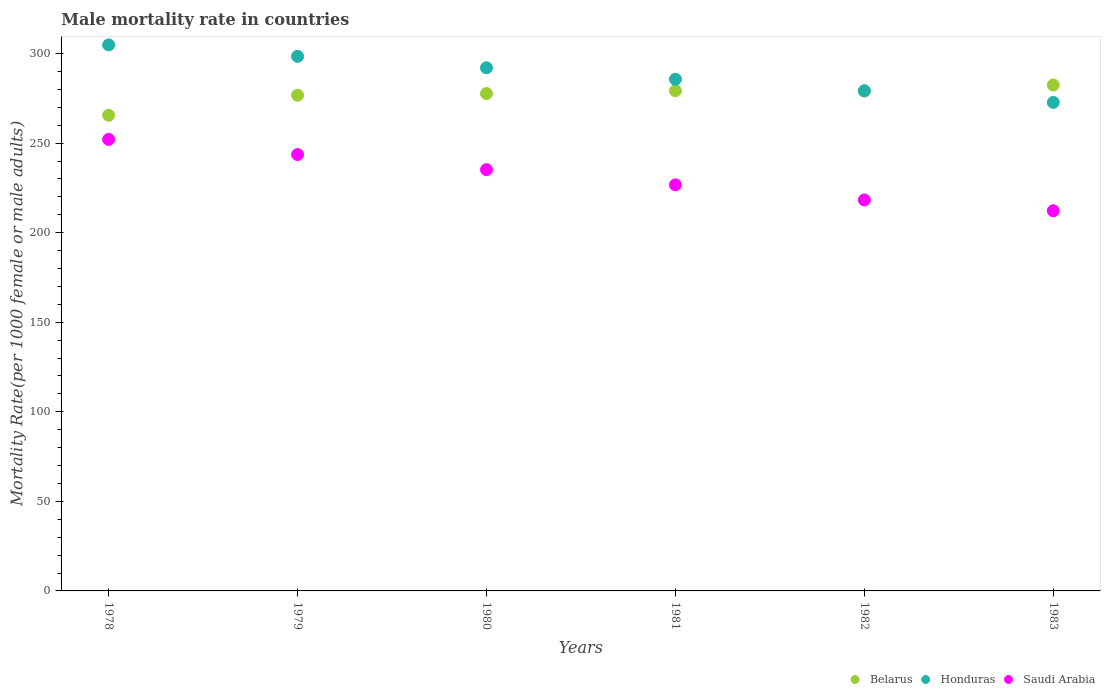How many different coloured dotlines are there?
Your answer should be compact. 3. What is the male mortality rate in Saudi Arabia in 1983?
Your answer should be compact. 212.25. Across all years, what is the maximum male mortality rate in Honduras?
Keep it short and to the point. 304.86. Across all years, what is the minimum male mortality rate in Honduras?
Offer a very short reply. 272.74. In which year was the male mortality rate in Saudi Arabia maximum?
Your response must be concise. 1978. In which year was the male mortality rate in Honduras minimum?
Provide a succinct answer. 1983. What is the total male mortality rate in Saudi Arabia in the graph?
Your answer should be compact. 1388.11. What is the difference between the male mortality rate in Belarus in 1978 and that in 1981?
Provide a succinct answer. -13.7. What is the difference between the male mortality rate in Saudi Arabia in 1983 and the male mortality rate in Belarus in 1982?
Your response must be concise. -66.8. What is the average male mortality rate in Saudi Arabia per year?
Your answer should be compact. 231.35. In the year 1983, what is the difference between the male mortality rate in Belarus and male mortality rate in Saudi Arabia?
Your response must be concise. 70.23. What is the ratio of the male mortality rate in Saudi Arabia in 1979 to that in 1982?
Keep it short and to the point. 1.12. Is the male mortality rate in Belarus in 1979 less than that in 1982?
Your answer should be compact. Yes. Is the difference between the male mortality rate in Belarus in 1979 and 1981 greater than the difference between the male mortality rate in Saudi Arabia in 1979 and 1981?
Your answer should be very brief. No. What is the difference between the highest and the second highest male mortality rate in Honduras?
Ensure brevity in your answer.  6.4. What is the difference between the highest and the lowest male mortality rate in Saudi Arabia?
Ensure brevity in your answer.  39.82. In how many years, is the male mortality rate in Honduras greater than the average male mortality rate in Honduras taken over all years?
Your response must be concise. 3. Is it the case that in every year, the sum of the male mortality rate in Belarus and male mortality rate in Honduras  is greater than the male mortality rate in Saudi Arabia?
Make the answer very short. Yes. Is the male mortality rate in Belarus strictly greater than the male mortality rate in Saudi Arabia over the years?
Your response must be concise. Yes. How many dotlines are there?
Provide a succinct answer. 3. How many years are there in the graph?
Offer a very short reply. 6. Does the graph contain grids?
Provide a succinct answer. No. Where does the legend appear in the graph?
Provide a short and direct response. Bottom right. How many legend labels are there?
Offer a terse response. 3. How are the legend labels stacked?
Your answer should be compact. Horizontal. What is the title of the graph?
Your answer should be compact. Male mortality rate in countries. What is the label or title of the X-axis?
Make the answer very short. Years. What is the label or title of the Y-axis?
Ensure brevity in your answer.  Mortality Rate(per 1000 female or male adults). What is the Mortality Rate(per 1000 female or male adults) in Belarus in 1978?
Offer a terse response. 265.55. What is the Mortality Rate(per 1000 female or male adults) in Honduras in 1978?
Your answer should be compact. 304.86. What is the Mortality Rate(per 1000 female or male adults) in Saudi Arabia in 1978?
Give a very brief answer. 252.07. What is the Mortality Rate(per 1000 female or male adults) in Belarus in 1979?
Your answer should be very brief. 276.74. What is the Mortality Rate(per 1000 female or male adults) in Honduras in 1979?
Provide a succinct answer. 298.46. What is the Mortality Rate(per 1000 female or male adults) in Saudi Arabia in 1979?
Give a very brief answer. 243.62. What is the Mortality Rate(per 1000 female or male adults) in Belarus in 1980?
Provide a short and direct response. 277.67. What is the Mortality Rate(per 1000 female or male adults) of Honduras in 1980?
Your answer should be very brief. 292.06. What is the Mortality Rate(per 1000 female or male adults) in Saudi Arabia in 1980?
Provide a succinct answer. 235.17. What is the Mortality Rate(per 1000 female or male adults) of Belarus in 1981?
Your answer should be very brief. 279.25. What is the Mortality Rate(per 1000 female or male adults) in Honduras in 1981?
Keep it short and to the point. 285.67. What is the Mortality Rate(per 1000 female or male adults) in Saudi Arabia in 1981?
Provide a short and direct response. 226.72. What is the Mortality Rate(per 1000 female or male adults) in Belarus in 1982?
Ensure brevity in your answer.  279.05. What is the Mortality Rate(per 1000 female or male adults) of Honduras in 1982?
Offer a very short reply. 279.27. What is the Mortality Rate(per 1000 female or male adults) in Saudi Arabia in 1982?
Offer a very short reply. 218.28. What is the Mortality Rate(per 1000 female or male adults) of Belarus in 1983?
Provide a short and direct response. 282.48. What is the Mortality Rate(per 1000 female or male adults) in Honduras in 1983?
Provide a succinct answer. 272.74. What is the Mortality Rate(per 1000 female or male adults) in Saudi Arabia in 1983?
Your response must be concise. 212.25. Across all years, what is the maximum Mortality Rate(per 1000 female or male adults) of Belarus?
Ensure brevity in your answer.  282.48. Across all years, what is the maximum Mortality Rate(per 1000 female or male adults) in Honduras?
Keep it short and to the point. 304.86. Across all years, what is the maximum Mortality Rate(per 1000 female or male adults) of Saudi Arabia?
Ensure brevity in your answer.  252.07. Across all years, what is the minimum Mortality Rate(per 1000 female or male adults) in Belarus?
Offer a terse response. 265.55. Across all years, what is the minimum Mortality Rate(per 1000 female or male adults) in Honduras?
Your answer should be compact. 272.74. Across all years, what is the minimum Mortality Rate(per 1000 female or male adults) of Saudi Arabia?
Provide a succinct answer. 212.25. What is the total Mortality Rate(per 1000 female or male adults) in Belarus in the graph?
Give a very brief answer. 1660.72. What is the total Mortality Rate(per 1000 female or male adults) in Honduras in the graph?
Provide a succinct answer. 1733.06. What is the total Mortality Rate(per 1000 female or male adults) of Saudi Arabia in the graph?
Make the answer very short. 1388.11. What is the difference between the Mortality Rate(per 1000 female or male adults) of Belarus in 1978 and that in 1979?
Offer a very short reply. -11.19. What is the difference between the Mortality Rate(per 1000 female or male adults) of Honduras in 1978 and that in 1979?
Ensure brevity in your answer.  6.4. What is the difference between the Mortality Rate(per 1000 female or male adults) in Saudi Arabia in 1978 and that in 1979?
Give a very brief answer. 8.45. What is the difference between the Mortality Rate(per 1000 female or male adults) in Belarus in 1978 and that in 1980?
Provide a succinct answer. -12.12. What is the difference between the Mortality Rate(per 1000 female or male adults) in Honduras in 1978 and that in 1980?
Offer a very short reply. 12.79. What is the difference between the Mortality Rate(per 1000 female or male adults) in Saudi Arabia in 1978 and that in 1980?
Keep it short and to the point. 16.9. What is the difference between the Mortality Rate(per 1000 female or male adults) in Belarus in 1978 and that in 1981?
Your response must be concise. -13.7. What is the difference between the Mortality Rate(per 1000 female or male adults) in Honduras in 1978 and that in 1981?
Offer a very short reply. 19.19. What is the difference between the Mortality Rate(per 1000 female or male adults) in Saudi Arabia in 1978 and that in 1981?
Ensure brevity in your answer.  25.34. What is the difference between the Mortality Rate(per 1000 female or male adults) of Belarus in 1978 and that in 1982?
Your answer should be very brief. -13.51. What is the difference between the Mortality Rate(per 1000 female or male adults) in Honduras in 1978 and that in 1982?
Provide a succinct answer. 25.59. What is the difference between the Mortality Rate(per 1000 female or male adults) in Saudi Arabia in 1978 and that in 1982?
Make the answer very short. 33.79. What is the difference between the Mortality Rate(per 1000 female or male adults) in Belarus in 1978 and that in 1983?
Keep it short and to the point. -16.93. What is the difference between the Mortality Rate(per 1000 female or male adults) of Honduras in 1978 and that in 1983?
Offer a terse response. 32.12. What is the difference between the Mortality Rate(per 1000 female or male adults) of Saudi Arabia in 1978 and that in 1983?
Your answer should be very brief. 39.82. What is the difference between the Mortality Rate(per 1000 female or male adults) of Belarus in 1979 and that in 1980?
Ensure brevity in your answer.  -0.93. What is the difference between the Mortality Rate(per 1000 female or male adults) in Honduras in 1979 and that in 1980?
Your answer should be compact. 6.4. What is the difference between the Mortality Rate(per 1000 female or male adults) in Saudi Arabia in 1979 and that in 1980?
Offer a very short reply. 8.45. What is the difference between the Mortality Rate(per 1000 female or male adults) of Belarus in 1979 and that in 1981?
Make the answer very short. -2.51. What is the difference between the Mortality Rate(per 1000 female or male adults) of Honduras in 1979 and that in 1981?
Provide a short and direct response. 12.79. What is the difference between the Mortality Rate(per 1000 female or male adults) in Saudi Arabia in 1979 and that in 1981?
Your answer should be very brief. 16.9. What is the difference between the Mortality Rate(per 1000 female or male adults) in Belarus in 1979 and that in 1982?
Give a very brief answer. -2.31. What is the difference between the Mortality Rate(per 1000 female or male adults) in Honduras in 1979 and that in 1982?
Keep it short and to the point. 19.19. What is the difference between the Mortality Rate(per 1000 female or male adults) of Saudi Arabia in 1979 and that in 1982?
Provide a succinct answer. 25.34. What is the difference between the Mortality Rate(per 1000 female or male adults) in Belarus in 1979 and that in 1983?
Offer a terse response. -5.74. What is the difference between the Mortality Rate(per 1000 female or male adults) of Honduras in 1979 and that in 1983?
Offer a terse response. 25.72. What is the difference between the Mortality Rate(per 1000 female or male adults) of Saudi Arabia in 1979 and that in 1983?
Ensure brevity in your answer.  31.37. What is the difference between the Mortality Rate(per 1000 female or male adults) of Belarus in 1980 and that in 1981?
Provide a succinct answer. -1.58. What is the difference between the Mortality Rate(per 1000 female or male adults) of Honduras in 1980 and that in 1981?
Ensure brevity in your answer.  6.4. What is the difference between the Mortality Rate(per 1000 female or male adults) of Saudi Arabia in 1980 and that in 1981?
Provide a succinct answer. 8.45. What is the difference between the Mortality Rate(per 1000 female or male adults) of Belarus in 1980 and that in 1982?
Your response must be concise. -1.39. What is the difference between the Mortality Rate(per 1000 female or male adults) of Honduras in 1980 and that in 1982?
Provide a succinct answer. 12.79. What is the difference between the Mortality Rate(per 1000 female or male adults) in Saudi Arabia in 1980 and that in 1982?
Keep it short and to the point. 16.9. What is the difference between the Mortality Rate(per 1000 female or male adults) of Belarus in 1980 and that in 1983?
Make the answer very short. -4.81. What is the difference between the Mortality Rate(per 1000 female or male adults) in Honduras in 1980 and that in 1983?
Keep it short and to the point. 19.32. What is the difference between the Mortality Rate(per 1000 female or male adults) of Saudi Arabia in 1980 and that in 1983?
Offer a very short reply. 22.92. What is the difference between the Mortality Rate(per 1000 female or male adults) of Belarus in 1981 and that in 1982?
Give a very brief answer. 0.19. What is the difference between the Mortality Rate(per 1000 female or male adults) of Honduras in 1981 and that in 1982?
Provide a succinct answer. 6.4. What is the difference between the Mortality Rate(per 1000 female or male adults) of Saudi Arabia in 1981 and that in 1982?
Ensure brevity in your answer.  8.45. What is the difference between the Mortality Rate(per 1000 female or male adults) in Belarus in 1981 and that in 1983?
Give a very brief answer. -3.23. What is the difference between the Mortality Rate(per 1000 female or male adults) of Honduras in 1981 and that in 1983?
Provide a short and direct response. 12.93. What is the difference between the Mortality Rate(per 1000 female or male adults) in Saudi Arabia in 1981 and that in 1983?
Provide a succinct answer. 14.48. What is the difference between the Mortality Rate(per 1000 female or male adults) of Belarus in 1982 and that in 1983?
Your answer should be compact. -3.42. What is the difference between the Mortality Rate(per 1000 female or male adults) in Honduras in 1982 and that in 1983?
Offer a very short reply. 6.53. What is the difference between the Mortality Rate(per 1000 female or male adults) in Saudi Arabia in 1982 and that in 1983?
Your response must be concise. 6.03. What is the difference between the Mortality Rate(per 1000 female or male adults) of Belarus in 1978 and the Mortality Rate(per 1000 female or male adults) of Honduras in 1979?
Keep it short and to the point. -32.91. What is the difference between the Mortality Rate(per 1000 female or male adults) of Belarus in 1978 and the Mortality Rate(per 1000 female or male adults) of Saudi Arabia in 1979?
Your answer should be compact. 21.93. What is the difference between the Mortality Rate(per 1000 female or male adults) of Honduras in 1978 and the Mortality Rate(per 1000 female or male adults) of Saudi Arabia in 1979?
Keep it short and to the point. 61.24. What is the difference between the Mortality Rate(per 1000 female or male adults) in Belarus in 1978 and the Mortality Rate(per 1000 female or male adults) in Honduras in 1980?
Your answer should be very brief. -26.52. What is the difference between the Mortality Rate(per 1000 female or male adults) of Belarus in 1978 and the Mortality Rate(per 1000 female or male adults) of Saudi Arabia in 1980?
Your answer should be very brief. 30.37. What is the difference between the Mortality Rate(per 1000 female or male adults) in Honduras in 1978 and the Mortality Rate(per 1000 female or male adults) in Saudi Arabia in 1980?
Your answer should be compact. 69.69. What is the difference between the Mortality Rate(per 1000 female or male adults) of Belarus in 1978 and the Mortality Rate(per 1000 female or male adults) of Honduras in 1981?
Your answer should be very brief. -20.12. What is the difference between the Mortality Rate(per 1000 female or male adults) of Belarus in 1978 and the Mortality Rate(per 1000 female or male adults) of Saudi Arabia in 1981?
Provide a short and direct response. 38.82. What is the difference between the Mortality Rate(per 1000 female or male adults) in Honduras in 1978 and the Mortality Rate(per 1000 female or male adults) in Saudi Arabia in 1981?
Provide a short and direct response. 78.13. What is the difference between the Mortality Rate(per 1000 female or male adults) in Belarus in 1978 and the Mortality Rate(per 1000 female or male adults) in Honduras in 1982?
Your answer should be compact. -13.73. What is the difference between the Mortality Rate(per 1000 female or male adults) of Belarus in 1978 and the Mortality Rate(per 1000 female or male adults) of Saudi Arabia in 1982?
Provide a short and direct response. 47.27. What is the difference between the Mortality Rate(per 1000 female or male adults) in Honduras in 1978 and the Mortality Rate(per 1000 female or male adults) in Saudi Arabia in 1982?
Your response must be concise. 86.58. What is the difference between the Mortality Rate(per 1000 female or male adults) in Belarus in 1978 and the Mortality Rate(per 1000 female or male adults) in Honduras in 1983?
Provide a short and direct response. -7.2. What is the difference between the Mortality Rate(per 1000 female or male adults) of Belarus in 1978 and the Mortality Rate(per 1000 female or male adults) of Saudi Arabia in 1983?
Keep it short and to the point. 53.3. What is the difference between the Mortality Rate(per 1000 female or male adults) of Honduras in 1978 and the Mortality Rate(per 1000 female or male adults) of Saudi Arabia in 1983?
Your answer should be compact. 92.61. What is the difference between the Mortality Rate(per 1000 female or male adults) of Belarus in 1979 and the Mortality Rate(per 1000 female or male adults) of Honduras in 1980?
Your answer should be compact. -15.32. What is the difference between the Mortality Rate(per 1000 female or male adults) of Belarus in 1979 and the Mortality Rate(per 1000 female or male adults) of Saudi Arabia in 1980?
Make the answer very short. 41.57. What is the difference between the Mortality Rate(per 1000 female or male adults) in Honduras in 1979 and the Mortality Rate(per 1000 female or male adults) in Saudi Arabia in 1980?
Provide a short and direct response. 63.29. What is the difference between the Mortality Rate(per 1000 female or male adults) of Belarus in 1979 and the Mortality Rate(per 1000 female or male adults) of Honduras in 1981?
Offer a terse response. -8.93. What is the difference between the Mortality Rate(per 1000 female or male adults) of Belarus in 1979 and the Mortality Rate(per 1000 female or male adults) of Saudi Arabia in 1981?
Make the answer very short. 50.02. What is the difference between the Mortality Rate(per 1000 female or male adults) of Honduras in 1979 and the Mortality Rate(per 1000 female or male adults) of Saudi Arabia in 1981?
Your answer should be very brief. 71.74. What is the difference between the Mortality Rate(per 1000 female or male adults) in Belarus in 1979 and the Mortality Rate(per 1000 female or male adults) in Honduras in 1982?
Your response must be concise. -2.53. What is the difference between the Mortality Rate(per 1000 female or male adults) of Belarus in 1979 and the Mortality Rate(per 1000 female or male adults) of Saudi Arabia in 1982?
Ensure brevity in your answer.  58.46. What is the difference between the Mortality Rate(per 1000 female or male adults) of Honduras in 1979 and the Mortality Rate(per 1000 female or male adults) of Saudi Arabia in 1982?
Keep it short and to the point. 80.19. What is the difference between the Mortality Rate(per 1000 female or male adults) in Belarus in 1979 and the Mortality Rate(per 1000 female or male adults) in Honduras in 1983?
Your answer should be compact. 4. What is the difference between the Mortality Rate(per 1000 female or male adults) of Belarus in 1979 and the Mortality Rate(per 1000 female or male adults) of Saudi Arabia in 1983?
Make the answer very short. 64.49. What is the difference between the Mortality Rate(per 1000 female or male adults) of Honduras in 1979 and the Mortality Rate(per 1000 female or male adults) of Saudi Arabia in 1983?
Make the answer very short. 86.21. What is the difference between the Mortality Rate(per 1000 female or male adults) of Belarus in 1980 and the Mortality Rate(per 1000 female or male adults) of Honduras in 1981?
Your response must be concise. -8. What is the difference between the Mortality Rate(per 1000 female or male adults) of Belarus in 1980 and the Mortality Rate(per 1000 female or male adults) of Saudi Arabia in 1981?
Ensure brevity in your answer.  50.94. What is the difference between the Mortality Rate(per 1000 female or male adults) in Honduras in 1980 and the Mortality Rate(per 1000 female or male adults) in Saudi Arabia in 1981?
Offer a very short reply. 65.34. What is the difference between the Mortality Rate(per 1000 female or male adults) in Belarus in 1980 and the Mortality Rate(per 1000 female or male adults) in Honduras in 1982?
Your answer should be compact. -1.61. What is the difference between the Mortality Rate(per 1000 female or male adults) of Belarus in 1980 and the Mortality Rate(per 1000 female or male adults) of Saudi Arabia in 1982?
Provide a short and direct response. 59.39. What is the difference between the Mortality Rate(per 1000 female or male adults) of Honduras in 1980 and the Mortality Rate(per 1000 female or male adults) of Saudi Arabia in 1982?
Your answer should be very brief. 73.79. What is the difference between the Mortality Rate(per 1000 female or male adults) of Belarus in 1980 and the Mortality Rate(per 1000 female or male adults) of Honduras in 1983?
Your answer should be very brief. 4.92. What is the difference between the Mortality Rate(per 1000 female or male adults) of Belarus in 1980 and the Mortality Rate(per 1000 female or male adults) of Saudi Arabia in 1983?
Offer a terse response. 65.42. What is the difference between the Mortality Rate(per 1000 female or male adults) of Honduras in 1980 and the Mortality Rate(per 1000 female or male adults) of Saudi Arabia in 1983?
Provide a short and direct response. 79.82. What is the difference between the Mortality Rate(per 1000 female or male adults) of Belarus in 1981 and the Mortality Rate(per 1000 female or male adults) of Honduras in 1982?
Offer a very short reply. -0.03. What is the difference between the Mortality Rate(per 1000 female or male adults) of Belarus in 1981 and the Mortality Rate(per 1000 female or male adults) of Saudi Arabia in 1982?
Your answer should be very brief. 60.97. What is the difference between the Mortality Rate(per 1000 female or male adults) in Honduras in 1981 and the Mortality Rate(per 1000 female or male adults) in Saudi Arabia in 1982?
Your response must be concise. 67.39. What is the difference between the Mortality Rate(per 1000 female or male adults) in Belarus in 1981 and the Mortality Rate(per 1000 female or male adults) in Honduras in 1983?
Ensure brevity in your answer.  6.5. What is the difference between the Mortality Rate(per 1000 female or male adults) of Belarus in 1981 and the Mortality Rate(per 1000 female or male adults) of Saudi Arabia in 1983?
Your answer should be very brief. 67. What is the difference between the Mortality Rate(per 1000 female or male adults) of Honduras in 1981 and the Mortality Rate(per 1000 female or male adults) of Saudi Arabia in 1983?
Provide a succinct answer. 73.42. What is the difference between the Mortality Rate(per 1000 female or male adults) in Belarus in 1982 and the Mortality Rate(per 1000 female or male adults) in Honduras in 1983?
Provide a short and direct response. 6.31. What is the difference between the Mortality Rate(per 1000 female or male adults) of Belarus in 1982 and the Mortality Rate(per 1000 female or male adults) of Saudi Arabia in 1983?
Provide a short and direct response. 66.8. What is the difference between the Mortality Rate(per 1000 female or male adults) of Honduras in 1982 and the Mortality Rate(per 1000 female or male adults) of Saudi Arabia in 1983?
Offer a terse response. 67.02. What is the average Mortality Rate(per 1000 female or male adults) in Belarus per year?
Offer a very short reply. 276.79. What is the average Mortality Rate(per 1000 female or male adults) of Honduras per year?
Keep it short and to the point. 288.84. What is the average Mortality Rate(per 1000 female or male adults) in Saudi Arabia per year?
Provide a succinct answer. 231.35. In the year 1978, what is the difference between the Mortality Rate(per 1000 female or male adults) in Belarus and Mortality Rate(per 1000 female or male adults) in Honduras?
Offer a very short reply. -39.31. In the year 1978, what is the difference between the Mortality Rate(per 1000 female or male adults) in Belarus and Mortality Rate(per 1000 female or male adults) in Saudi Arabia?
Your answer should be compact. 13.48. In the year 1978, what is the difference between the Mortality Rate(per 1000 female or male adults) in Honduras and Mortality Rate(per 1000 female or male adults) in Saudi Arabia?
Give a very brief answer. 52.79. In the year 1979, what is the difference between the Mortality Rate(per 1000 female or male adults) in Belarus and Mortality Rate(per 1000 female or male adults) in Honduras?
Keep it short and to the point. -21.72. In the year 1979, what is the difference between the Mortality Rate(per 1000 female or male adults) in Belarus and Mortality Rate(per 1000 female or male adults) in Saudi Arabia?
Make the answer very short. 33.12. In the year 1979, what is the difference between the Mortality Rate(per 1000 female or male adults) in Honduras and Mortality Rate(per 1000 female or male adults) in Saudi Arabia?
Offer a very short reply. 54.84. In the year 1980, what is the difference between the Mortality Rate(per 1000 female or male adults) in Belarus and Mortality Rate(per 1000 female or male adults) in Honduras?
Offer a terse response. -14.4. In the year 1980, what is the difference between the Mortality Rate(per 1000 female or male adults) of Belarus and Mortality Rate(per 1000 female or male adults) of Saudi Arabia?
Provide a short and direct response. 42.49. In the year 1980, what is the difference between the Mortality Rate(per 1000 female or male adults) of Honduras and Mortality Rate(per 1000 female or male adults) of Saudi Arabia?
Keep it short and to the point. 56.89. In the year 1981, what is the difference between the Mortality Rate(per 1000 female or male adults) in Belarus and Mortality Rate(per 1000 female or male adults) in Honduras?
Offer a terse response. -6.42. In the year 1981, what is the difference between the Mortality Rate(per 1000 female or male adults) in Belarus and Mortality Rate(per 1000 female or male adults) in Saudi Arabia?
Your answer should be very brief. 52.52. In the year 1981, what is the difference between the Mortality Rate(per 1000 female or male adults) of Honduras and Mortality Rate(per 1000 female or male adults) of Saudi Arabia?
Keep it short and to the point. 58.94. In the year 1982, what is the difference between the Mortality Rate(per 1000 female or male adults) of Belarus and Mortality Rate(per 1000 female or male adults) of Honduras?
Make the answer very short. -0.22. In the year 1982, what is the difference between the Mortality Rate(per 1000 female or male adults) of Belarus and Mortality Rate(per 1000 female or male adults) of Saudi Arabia?
Provide a succinct answer. 60.78. In the year 1982, what is the difference between the Mortality Rate(per 1000 female or male adults) of Honduras and Mortality Rate(per 1000 female or male adults) of Saudi Arabia?
Keep it short and to the point. 61. In the year 1983, what is the difference between the Mortality Rate(per 1000 female or male adults) of Belarus and Mortality Rate(per 1000 female or male adults) of Honduras?
Provide a succinct answer. 9.73. In the year 1983, what is the difference between the Mortality Rate(per 1000 female or male adults) of Belarus and Mortality Rate(per 1000 female or male adults) of Saudi Arabia?
Your answer should be compact. 70.23. In the year 1983, what is the difference between the Mortality Rate(per 1000 female or male adults) in Honduras and Mortality Rate(per 1000 female or male adults) in Saudi Arabia?
Give a very brief answer. 60.49. What is the ratio of the Mortality Rate(per 1000 female or male adults) of Belarus in 1978 to that in 1979?
Give a very brief answer. 0.96. What is the ratio of the Mortality Rate(per 1000 female or male adults) of Honduras in 1978 to that in 1979?
Offer a very short reply. 1.02. What is the ratio of the Mortality Rate(per 1000 female or male adults) in Saudi Arabia in 1978 to that in 1979?
Make the answer very short. 1.03. What is the ratio of the Mortality Rate(per 1000 female or male adults) in Belarus in 1978 to that in 1980?
Give a very brief answer. 0.96. What is the ratio of the Mortality Rate(per 1000 female or male adults) of Honduras in 1978 to that in 1980?
Offer a terse response. 1.04. What is the ratio of the Mortality Rate(per 1000 female or male adults) in Saudi Arabia in 1978 to that in 1980?
Provide a short and direct response. 1.07. What is the ratio of the Mortality Rate(per 1000 female or male adults) in Belarus in 1978 to that in 1981?
Give a very brief answer. 0.95. What is the ratio of the Mortality Rate(per 1000 female or male adults) of Honduras in 1978 to that in 1981?
Your response must be concise. 1.07. What is the ratio of the Mortality Rate(per 1000 female or male adults) of Saudi Arabia in 1978 to that in 1981?
Offer a terse response. 1.11. What is the ratio of the Mortality Rate(per 1000 female or male adults) in Belarus in 1978 to that in 1982?
Offer a terse response. 0.95. What is the ratio of the Mortality Rate(per 1000 female or male adults) in Honduras in 1978 to that in 1982?
Provide a short and direct response. 1.09. What is the ratio of the Mortality Rate(per 1000 female or male adults) of Saudi Arabia in 1978 to that in 1982?
Provide a short and direct response. 1.15. What is the ratio of the Mortality Rate(per 1000 female or male adults) of Belarus in 1978 to that in 1983?
Provide a short and direct response. 0.94. What is the ratio of the Mortality Rate(per 1000 female or male adults) in Honduras in 1978 to that in 1983?
Your answer should be compact. 1.12. What is the ratio of the Mortality Rate(per 1000 female or male adults) in Saudi Arabia in 1978 to that in 1983?
Offer a very short reply. 1.19. What is the ratio of the Mortality Rate(per 1000 female or male adults) in Honduras in 1979 to that in 1980?
Keep it short and to the point. 1.02. What is the ratio of the Mortality Rate(per 1000 female or male adults) in Saudi Arabia in 1979 to that in 1980?
Keep it short and to the point. 1.04. What is the ratio of the Mortality Rate(per 1000 female or male adults) of Belarus in 1979 to that in 1981?
Your answer should be very brief. 0.99. What is the ratio of the Mortality Rate(per 1000 female or male adults) in Honduras in 1979 to that in 1981?
Your answer should be compact. 1.04. What is the ratio of the Mortality Rate(per 1000 female or male adults) in Saudi Arabia in 1979 to that in 1981?
Your answer should be very brief. 1.07. What is the ratio of the Mortality Rate(per 1000 female or male adults) in Honduras in 1979 to that in 1982?
Your answer should be compact. 1.07. What is the ratio of the Mortality Rate(per 1000 female or male adults) in Saudi Arabia in 1979 to that in 1982?
Your answer should be very brief. 1.12. What is the ratio of the Mortality Rate(per 1000 female or male adults) in Belarus in 1979 to that in 1983?
Ensure brevity in your answer.  0.98. What is the ratio of the Mortality Rate(per 1000 female or male adults) in Honduras in 1979 to that in 1983?
Offer a terse response. 1.09. What is the ratio of the Mortality Rate(per 1000 female or male adults) of Saudi Arabia in 1979 to that in 1983?
Ensure brevity in your answer.  1.15. What is the ratio of the Mortality Rate(per 1000 female or male adults) in Honduras in 1980 to that in 1981?
Make the answer very short. 1.02. What is the ratio of the Mortality Rate(per 1000 female or male adults) of Saudi Arabia in 1980 to that in 1981?
Offer a very short reply. 1.04. What is the ratio of the Mortality Rate(per 1000 female or male adults) in Belarus in 1980 to that in 1982?
Keep it short and to the point. 0.99. What is the ratio of the Mortality Rate(per 1000 female or male adults) in Honduras in 1980 to that in 1982?
Your response must be concise. 1.05. What is the ratio of the Mortality Rate(per 1000 female or male adults) in Saudi Arabia in 1980 to that in 1982?
Your response must be concise. 1.08. What is the ratio of the Mortality Rate(per 1000 female or male adults) in Honduras in 1980 to that in 1983?
Provide a succinct answer. 1.07. What is the ratio of the Mortality Rate(per 1000 female or male adults) in Saudi Arabia in 1980 to that in 1983?
Provide a short and direct response. 1.11. What is the ratio of the Mortality Rate(per 1000 female or male adults) of Belarus in 1981 to that in 1982?
Provide a succinct answer. 1. What is the ratio of the Mortality Rate(per 1000 female or male adults) in Honduras in 1981 to that in 1982?
Provide a succinct answer. 1.02. What is the ratio of the Mortality Rate(per 1000 female or male adults) in Saudi Arabia in 1981 to that in 1982?
Offer a terse response. 1.04. What is the ratio of the Mortality Rate(per 1000 female or male adults) in Honduras in 1981 to that in 1983?
Your response must be concise. 1.05. What is the ratio of the Mortality Rate(per 1000 female or male adults) of Saudi Arabia in 1981 to that in 1983?
Make the answer very short. 1.07. What is the ratio of the Mortality Rate(per 1000 female or male adults) of Belarus in 1982 to that in 1983?
Your answer should be compact. 0.99. What is the ratio of the Mortality Rate(per 1000 female or male adults) of Honduras in 1982 to that in 1983?
Offer a terse response. 1.02. What is the ratio of the Mortality Rate(per 1000 female or male adults) of Saudi Arabia in 1982 to that in 1983?
Your answer should be compact. 1.03. What is the difference between the highest and the second highest Mortality Rate(per 1000 female or male adults) in Belarus?
Make the answer very short. 3.23. What is the difference between the highest and the second highest Mortality Rate(per 1000 female or male adults) in Honduras?
Offer a terse response. 6.4. What is the difference between the highest and the second highest Mortality Rate(per 1000 female or male adults) of Saudi Arabia?
Provide a short and direct response. 8.45. What is the difference between the highest and the lowest Mortality Rate(per 1000 female or male adults) of Belarus?
Provide a succinct answer. 16.93. What is the difference between the highest and the lowest Mortality Rate(per 1000 female or male adults) in Honduras?
Provide a short and direct response. 32.12. What is the difference between the highest and the lowest Mortality Rate(per 1000 female or male adults) of Saudi Arabia?
Offer a very short reply. 39.82. 